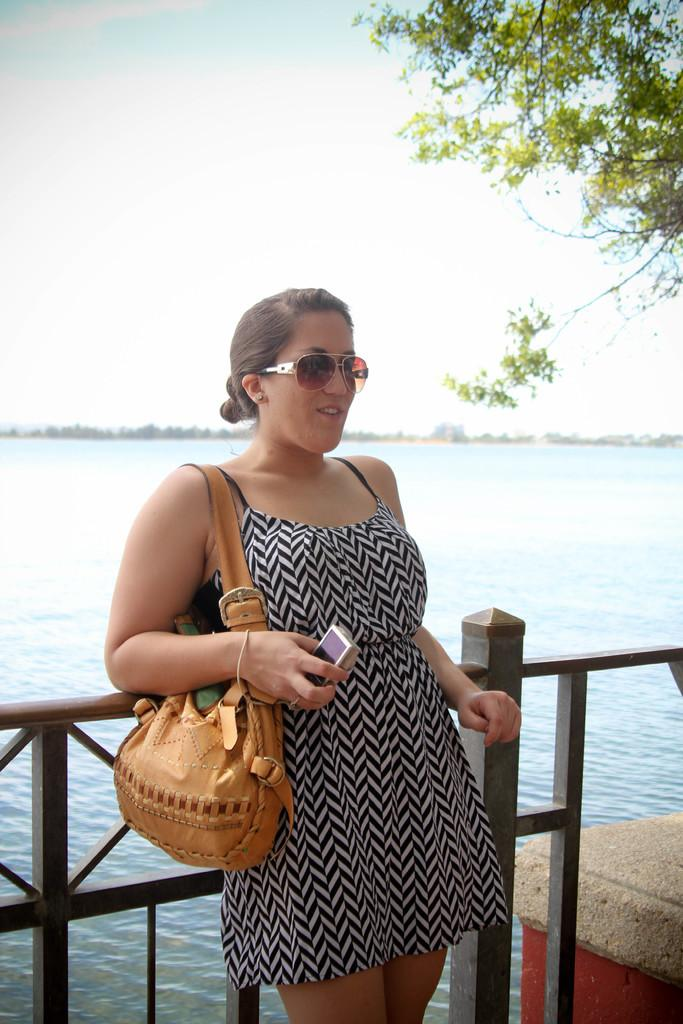What is the main subject of the image? There is a woman in the image. What is the woman doing in the image? The woman is standing in the image. What accessories is the woman wearing? The woman is wearing a handbag and goggles in the image. What is the woman holding in her hand? The woman is holding a camera in her hand. What can be seen in the background of the image? There is a river-like body of water and a tree in the background. What type of destruction can be seen happening to the geese in the image? There are no geese present in the image, and therefore no destruction can be observed. 